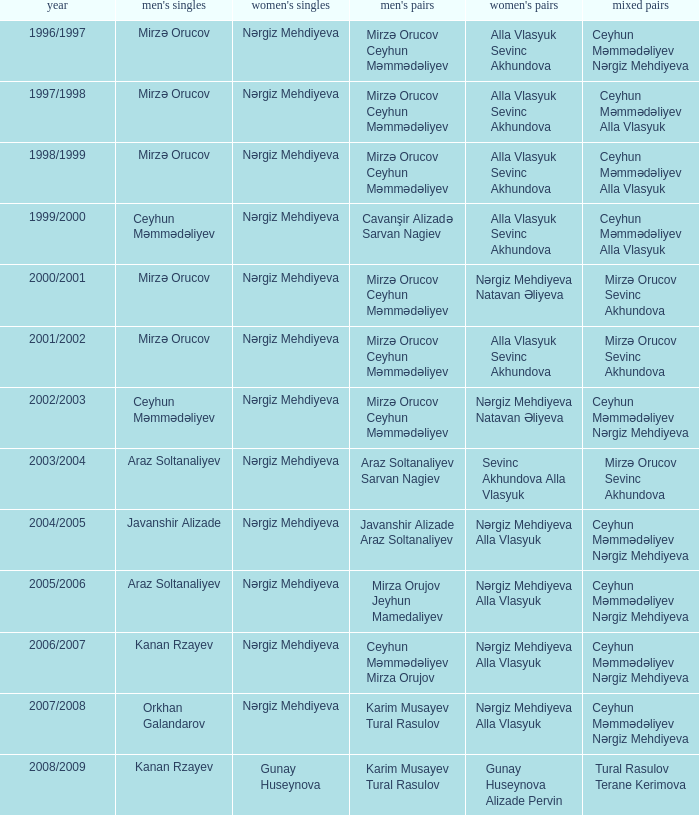Who are all the womens doubles for the year 2008/2009? Gunay Huseynova Alizade Pervin. 